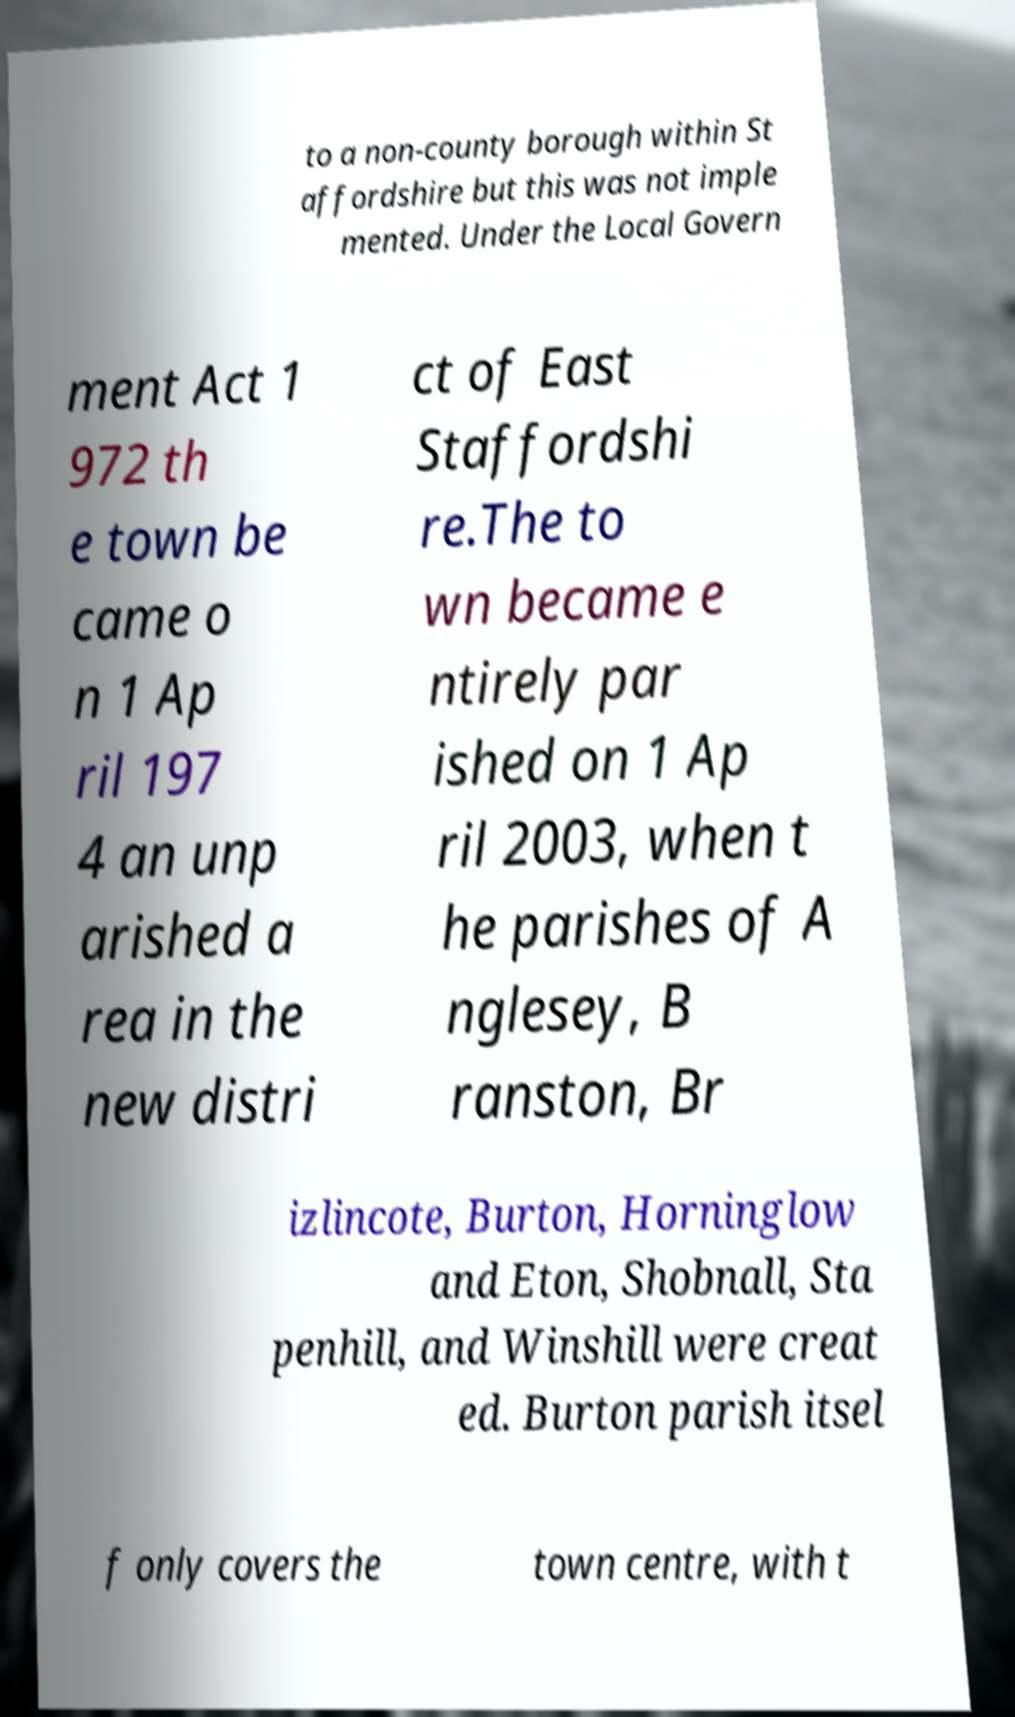For documentation purposes, I need the text within this image transcribed. Could you provide that? to a non-county borough within St affordshire but this was not imple mented. Under the Local Govern ment Act 1 972 th e town be came o n 1 Ap ril 197 4 an unp arished a rea in the new distri ct of East Staffordshi re.The to wn became e ntirely par ished on 1 Ap ril 2003, when t he parishes of A nglesey, B ranston, Br izlincote, Burton, Horninglow and Eton, Shobnall, Sta penhill, and Winshill were creat ed. Burton parish itsel f only covers the town centre, with t 